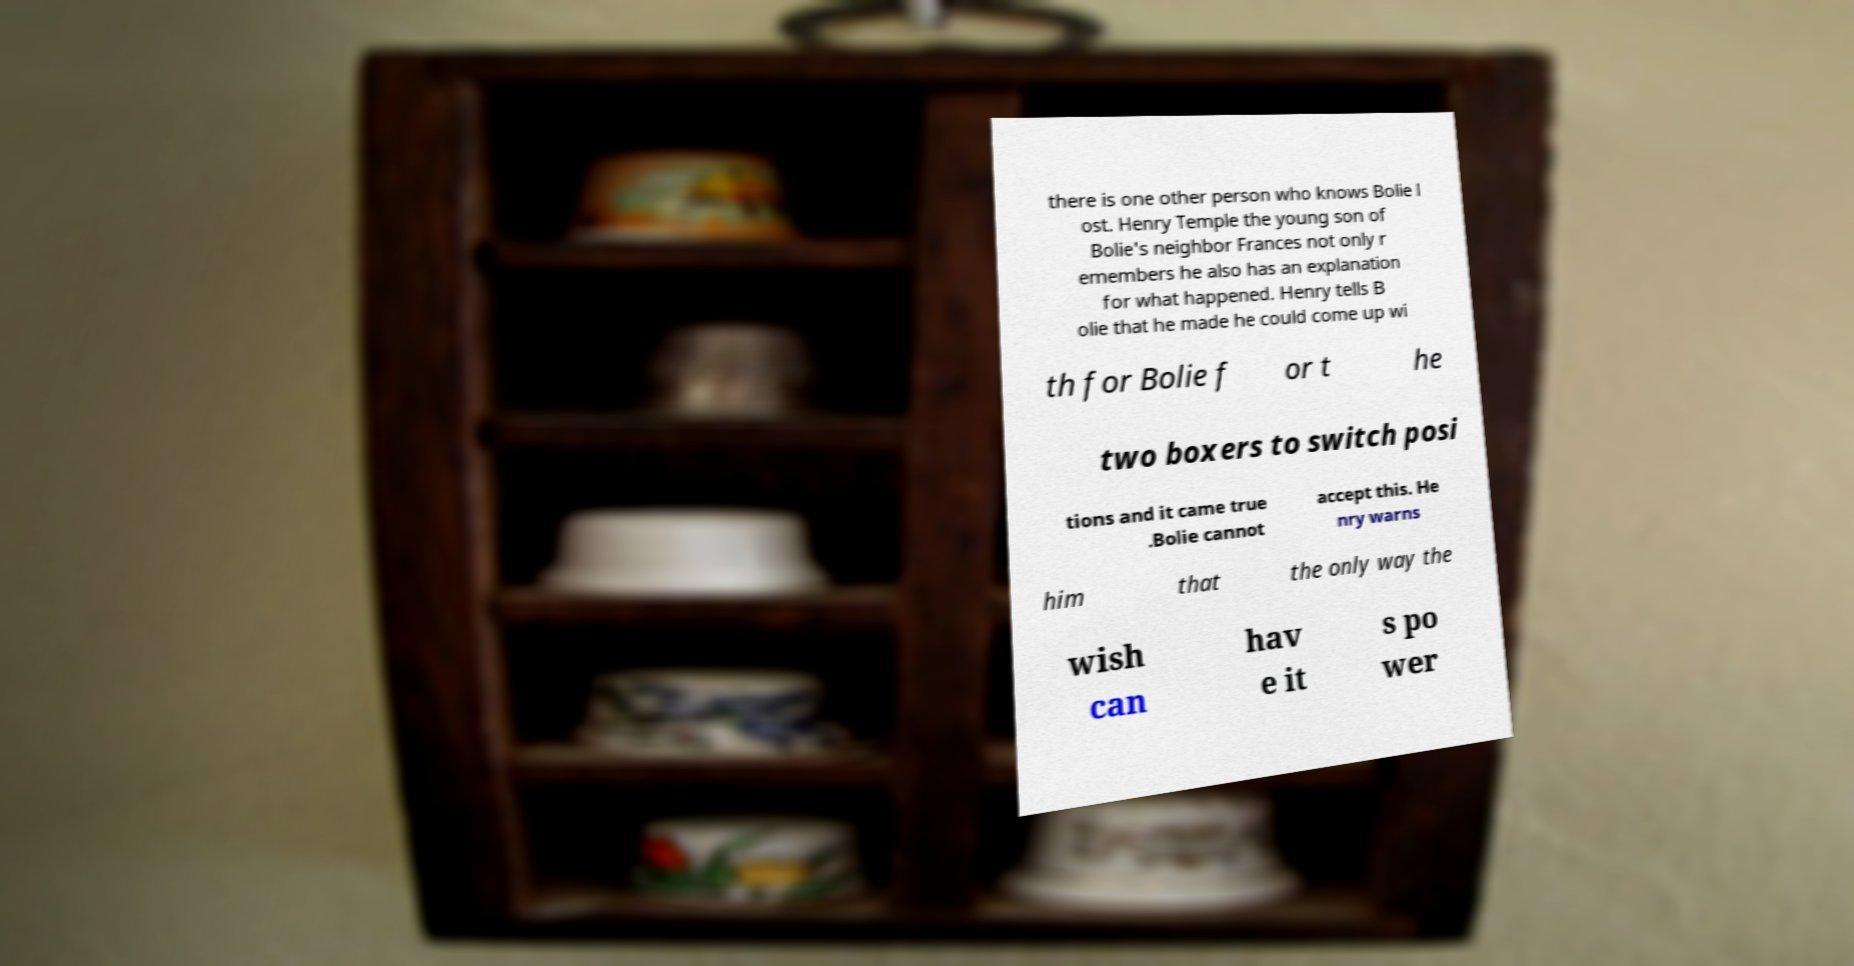Please identify and transcribe the text found in this image. there is one other person who knows Bolie l ost. Henry Temple the young son of Bolie's neighbor Frances not only r emembers he also has an explanation for what happened. Henry tells B olie that he made he could come up wi th for Bolie f or t he two boxers to switch posi tions and it came true .Bolie cannot accept this. He nry warns him that the only way the wish can hav e it s po wer 